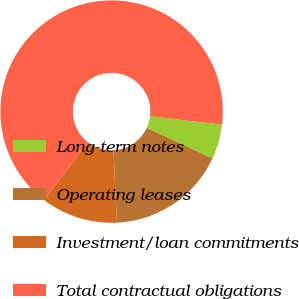Convert chart. <chart><loc_0><loc_0><loc_500><loc_500><pie_chart><fcel>Long-term notes<fcel>Operating leases<fcel>Investment/loan commitments<fcel>Total contractual obligations<nl><fcel>5.03%<fcel>17.32%<fcel>11.18%<fcel>66.47%<nl></chart> 